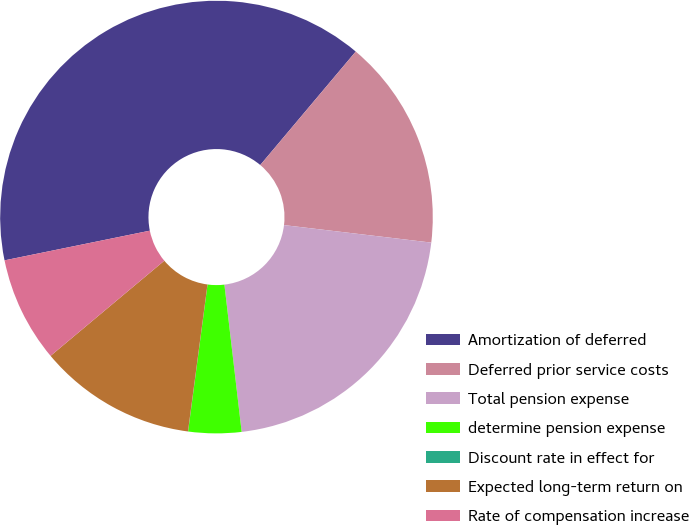Convert chart to OTSL. <chart><loc_0><loc_0><loc_500><loc_500><pie_chart><fcel>Amortization of deferred<fcel>Deferred prior service costs<fcel>Total pension expense<fcel>determine pension expense<fcel>Discount rate in effect for<fcel>Expected long-term return on<fcel>Rate of compensation increase<nl><fcel>39.34%<fcel>15.75%<fcel>21.26%<fcel>3.95%<fcel>0.01%<fcel>11.81%<fcel>7.88%<nl></chart> 